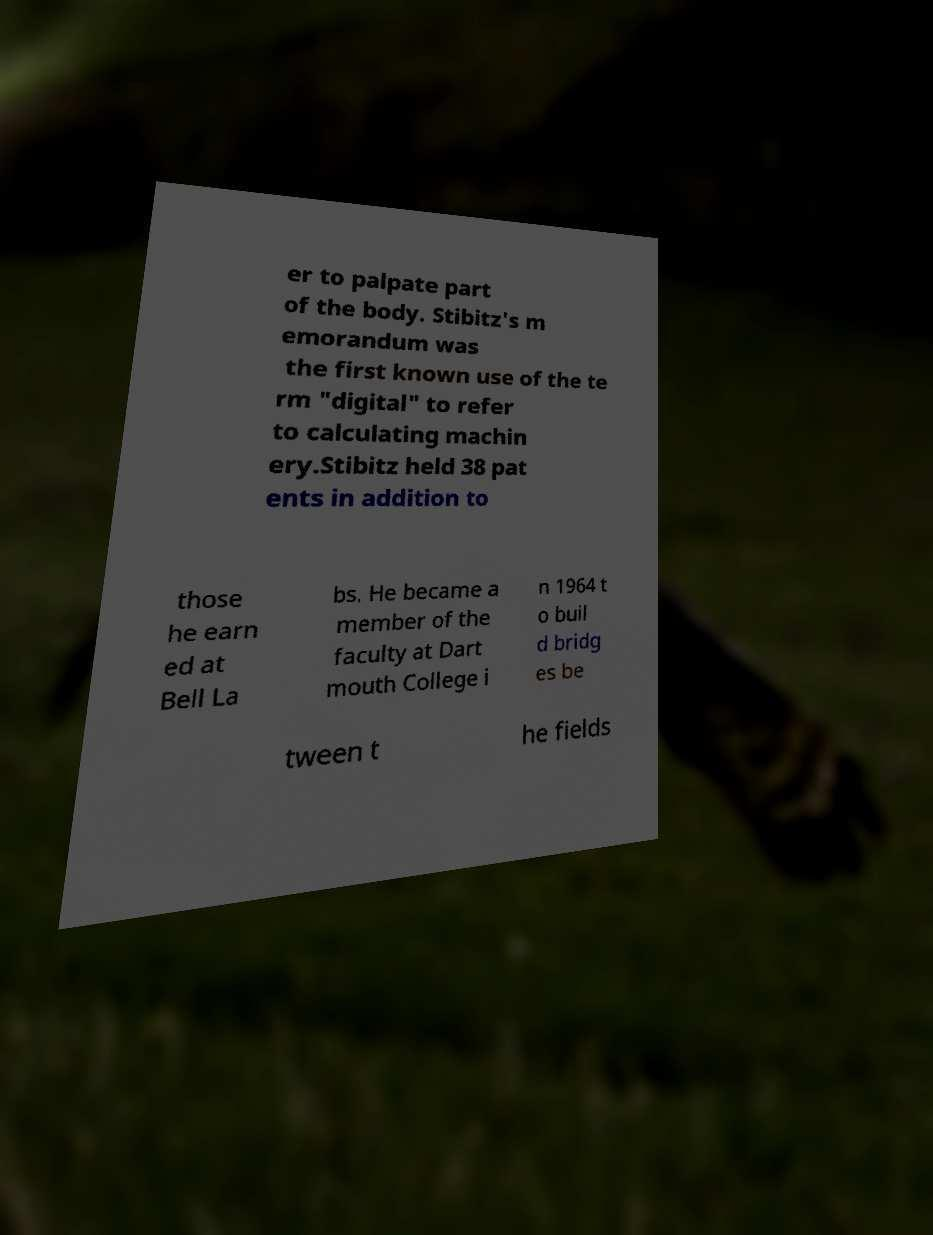There's text embedded in this image that I need extracted. Can you transcribe it verbatim? er to palpate part of the body. Stibitz's m emorandum was the first known use of the te rm "digital" to refer to calculating machin ery.Stibitz held 38 pat ents in addition to those he earn ed at Bell La bs. He became a member of the faculty at Dart mouth College i n 1964 t o buil d bridg es be tween t he fields 